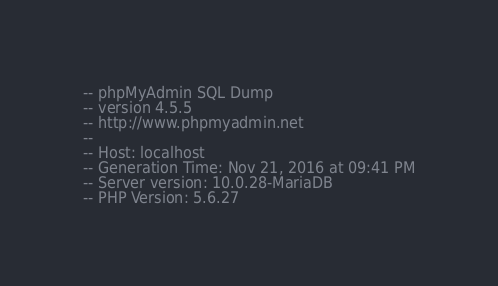<code> <loc_0><loc_0><loc_500><loc_500><_SQL_>-- phpMyAdmin SQL Dump
-- version 4.5.5
-- http://www.phpmyadmin.net
--
-- Host: localhost
-- Generation Time: Nov 21, 2016 at 09:41 PM
-- Server version: 10.0.28-MariaDB
-- PHP Version: 5.6.27
</code> 